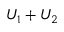<formula> <loc_0><loc_0><loc_500><loc_500>U _ { 1 } + U _ { 2 }</formula> 